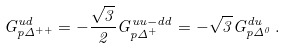Convert formula to latex. <formula><loc_0><loc_0><loc_500><loc_500>G ^ { u d } _ { p { \mathit \Delta } ^ { + + } } = - \frac { \sqrt { 3 } } { 2 } G ^ { u u - d d } _ { p { \mathit \Delta } ^ { + } } = - \sqrt { 3 } G ^ { d u } _ { p { \mathit \Delta } ^ { 0 } } \, .</formula> 